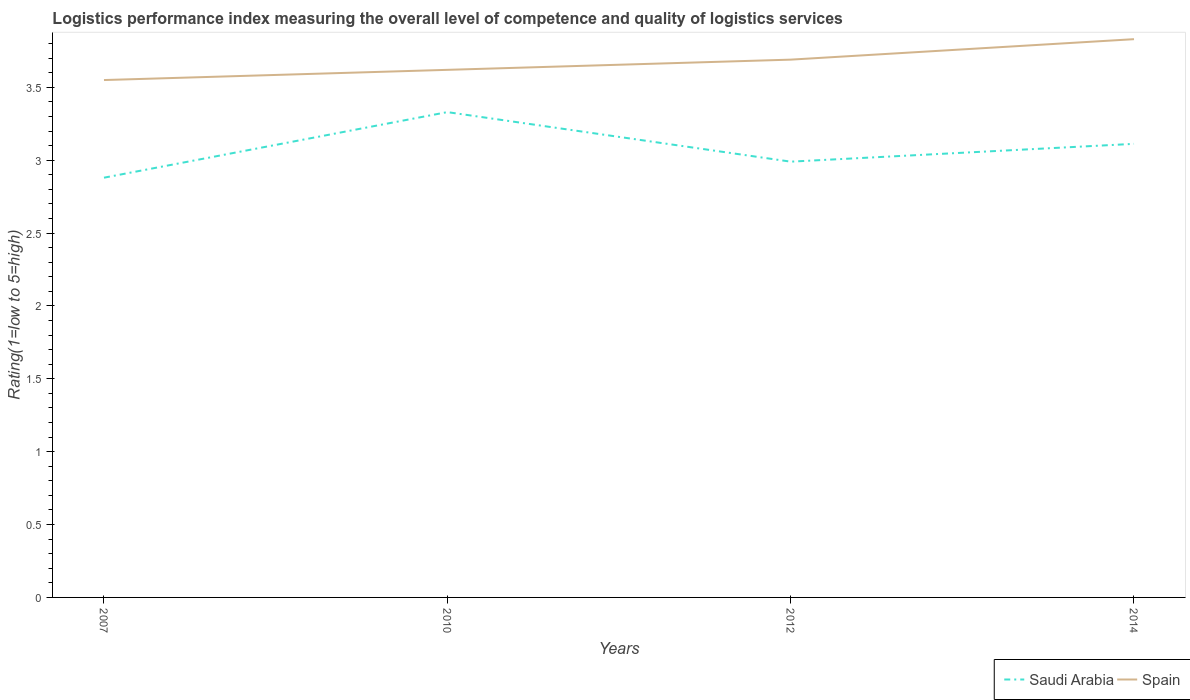How many different coloured lines are there?
Your answer should be compact. 2. Across all years, what is the maximum Logistic performance index in Spain?
Provide a succinct answer. 3.55. In which year was the Logistic performance index in Saudi Arabia maximum?
Give a very brief answer. 2007. What is the total Logistic performance index in Spain in the graph?
Your response must be concise. -0.07. What is the difference between the highest and the second highest Logistic performance index in Saudi Arabia?
Offer a terse response. 0.45. What is the difference between the highest and the lowest Logistic performance index in Spain?
Your answer should be very brief. 2. How many lines are there?
Offer a terse response. 2. How many years are there in the graph?
Your answer should be compact. 4. What is the difference between two consecutive major ticks on the Y-axis?
Provide a short and direct response. 0.5. Does the graph contain grids?
Give a very brief answer. No. Where does the legend appear in the graph?
Your answer should be compact. Bottom right. How many legend labels are there?
Your answer should be compact. 2. What is the title of the graph?
Your answer should be compact. Logistics performance index measuring the overall level of competence and quality of logistics services. What is the label or title of the Y-axis?
Ensure brevity in your answer.  Rating(1=low to 5=high). What is the Rating(1=low to 5=high) in Saudi Arabia in 2007?
Your response must be concise. 2.88. What is the Rating(1=low to 5=high) of Spain in 2007?
Give a very brief answer. 3.55. What is the Rating(1=low to 5=high) in Saudi Arabia in 2010?
Offer a very short reply. 3.33. What is the Rating(1=low to 5=high) of Spain in 2010?
Ensure brevity in your answer.  3.62. What is the Rating(1=low to 5=high) of Saudi Arabia in 2012?
Your answer should be very brief. 2.99. What is the Rating(1=low to 5=high) of Spain in 2012?
Provide a short and direct response. 3.69. What is the Rating(1=low to 5=high) of Saudi Arabia in 2014?
Your answer should be compact. 3.11. What is the Rating(1=low to 5=high) in Spain in 2014?
Give a very brief answer. 3.83. Across all years, what is the maximum Rating(1=low to 5=high) in Saudi Arabia?
Provide a succinct answer. 3.33. Across all years, what is the maximum Rating(1=low to 5=high) in Spain?
Your answer should be very brief. 3.83. Across all years, what is the minimum Rating(1=low to 5=high) in Saudi Arabia?
Your answer should be very brief. 2.88. Across all years, what is the minimum Rating(1=low to 5=high) in Spain?
Offer a terse response. 3.55. What is the total Rating(1=low to 5=high) in Saudi Arabia in the graph?
Keep it short and to the point. 12.31. What is the total Rating(1=low to 5=high) in Spain in the graph?
Provide a succinct answer. 14.69. What is the difference between the Rating(1=low to 5=high) in Saudi Arabia in 2007 and that in 2010?
Provide a short and direct response. -0.45. What is the difference between the Rating(1=low to 5=high) of Spain in 2007 and that in 2010?
Your answer should be compact. -0.07. What is the difference between the Rating(1=low to 5=high) in Saudi Arabia in 2007 and that in 2012?
Give a very brief answer. -0.11. What is the difference between the Rating(1=low to 5=high) of Spain in 2007 and that in 2012?
Offer a very short reply. -0.14. What is the difference between the Rating(1=low to 5=high) of Saudi Arabia in 2007 and that in 2014?
Your answer should be compact. -0.23. What is the difference between the Rating(1=low to 5=high) in Spain in 2007 and that in 2014?
Ensure brevity in your answer.  -0.28. What is the difference between the Rating(1=low to 5=high) in Saudi Arabia in 2010 and that in 2012?
Make the answer very short. 0.34. What is the difference between the Rating(1=low to 5=high) of Spain in 2010 and that in 2012?
Your answer should be very brief. -0.07. What is the difference between the Rating(1=low to 5=high) in Saudi Arabia in 2010 and that in 2014?
Provide a succinct answer. 0.22. What is the difference between the Rating(1=low to 5=high) in Spain in 2010 and that in 2014?
Provide a short and direct response. -0.21. What is the difference between the Rating(1=low to 5=high) of Saudi Arabia in 2012 and that in 2014?
Ensure brevity in your answer.  -0.12. What is the difference between the Rating(1=low to 5=high) in Spain in 2012 and that in 2014?
Offer a terse response. -0.14. What is the difference between the Rating(1=low to 5=high) of Saudi Arabia in 2007 and the Rating(1=low to 5=high) of Spain in 2010?
Provide a succinct answer. -0.74. What is the difference between the Rating(1=low to 5=high) of Saudi Arabia in 2007 and the Rating(1=low to 5=high) of Spain in 2012?
Provide a succinct answer. -0.81. What is the difference between the Rating(1=low to 5=high) in Saudi Arabia in 2007 and the Rating(1=low to 5=high) in Spain in 2014?
Make the answer very short. -0.95. What is the difference between the Rating(1=low to 5=high) of Saudi Arabia in 2010 and the Rating(1=low to 5=high) of Spain in 2012?
Your answer should be very brief. -0.36. What is the difference between the Rating(1=low to 5=high) in Saudi Arabia in 2010 and the Rating(1=low to 5=high) in Spain in 2014?
Provide a succinct answer. -0.5. What is the difference between the Rating(1=low to 5=high) in Saudi Arabia in 2012 and the Rating(1=low to 5=high) in Spain in 2014?
Provide a short and direct response. -0.84. What is the average Rating(1=low to 5=high) in Saudi Arabia per year?
Your response must be concise. 3.08. What is the average Rating(1=low to 5=high) of Spain per year?
Ensure brevity in your answer.  3.67. In the year 2007, what is the difference between the Rating(1=low to 5=high) in Saudi Arabia and Rating(1=low to 5=high) in Spain?
Ensure brevity in your answer.  -0.67. In the year 2010, what is the difference between the Rating(1=low to 5=high) of Saudi Arabia and Rating(1=low to 5=high) of Spain?
Your response must be concise. -0.29. In the year 2012, what is the difference between the Rating(1=low to 5=high) in Saudi Arabia and Rating(1=low to 5=high) in Spain?
Ensure brevity in your answer.  -0.7. In the year 2014, what is the difference between the Rating(1=low to 5=high) of Saudi Arabia and Rating(1=low to 5=high) of Spain?
Provide a succinct answer. -0.72. What is the ratio of the Rating(1=low to 5=high) in Saudi Arabia in 2007 to that in 2010?
Provide a short and direct response. 0.86. What is the ratio of the Rating(1=low to 5=high) in Spain in 2007 to that in 2010?
Keep it short and to the point. 0.98. What is the ratio of the Rating(1=low to 5=high) of Saudi Arabia in 2007 to that in 2012?
Make the answer very short. 0.96. What is the ratio of the Rating(1=low to 5=high) in Spain in 2007 to that in 2012?
Your answer should be compact. 0.96. What is the ratio of the Rating(1=low to 5=high) in Saudi Arabia in 2007 to that in 2014?
Keep it short and to the point. 0.93. What is the ratio of the Rating(1=low to 5=high) in Spain in 2007 to that in 2014?
Your answer should be compact. 0.93. What is the ratio of the Rating(1=low to 5=high) in Saudi Arabia in 2010 to that in 2012?
Keep it short and to the point. 1.11. What is the ratio of the Rating(1=low to 5=high) in Spain in 2010 to that in 2012?
Provide a succinct answer. 0.98. What is the ratio of the Rating(1=low to 5=high) of Saudi Arabia in 2010 to that in 2014?
Your answer should be compact. 1.07. What is the ratio of the Rating(1=low to 5=high) in Spain in 2010 to that in 2014?
Your response must be concise. 0.95. What is the ratio of the Rating(1=low to 5=high) of Saudi Arabia in 2012 to that in 2014?
Offer a very short reply. 0.96. What is the ratio of the Rating(1=low to 5=high) of Spain in 2012 to that in 2014?
Keep it short and to the point. 0.96. What is the difference between the highest and the second highest Rating(1=low to 5=high) in Saudi Arabia?
Offer a very short reply. 0.22. What is the difference between the highest and the second highest Rating(1=low to 5=high) in Spain?
Your response must be concise. 0.14. What is the difference between the highest and the lowest Rating(1=low to 5=high) in Saudi Arabia?
Provide a succinct answer. 0.45. What is the difference between the highest and the lowest Rating(1=low to 5=high) of Spain?
Provide a succinct answer. 0.28. 